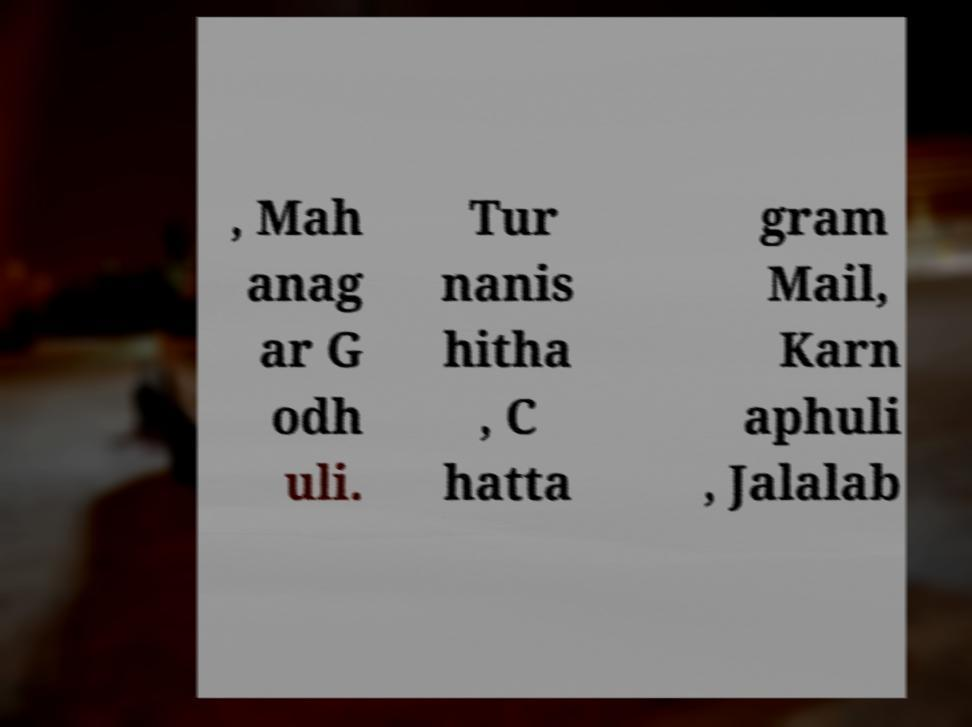Please read and relay the text visible in this image. What does it say? , Mah anag ar G odh uli. Tur nanis hitha , C hatta gram Mail, Karn aphuli , Jalalab 